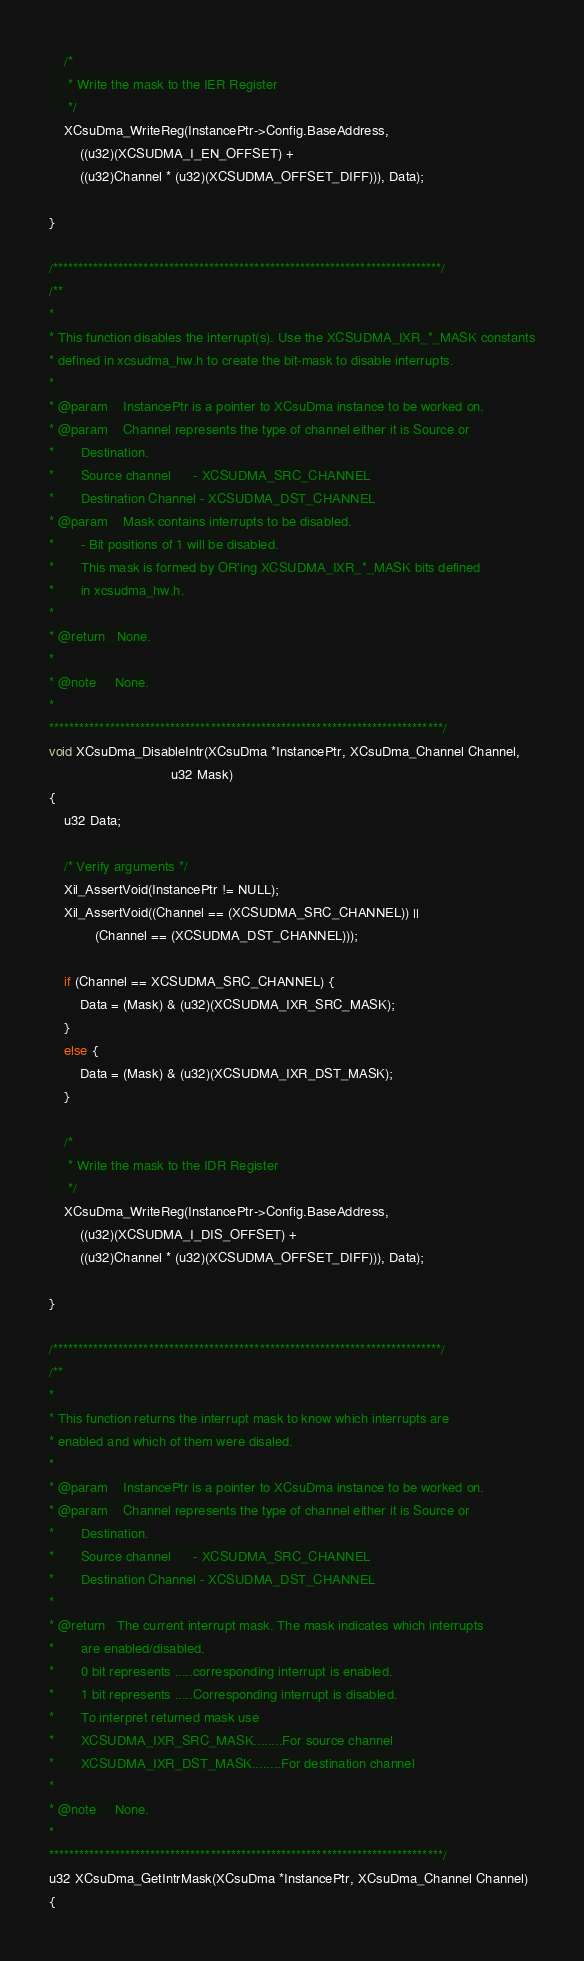<code> <loc_0><loc_0><loc_500><loc_500><_C_>	/*
	 * Write the mask to the IER Register
	 */
	XCsuDma_WriteReg(InstancePtr->Config.BaseAddress,
		((u32)(XCSUDMA_I_EN_OFFSET) +
		((u32)Channel * (u32)(XCSUDMA_OFFSET_DIFF))), Data);

}

/*****************************************************************************/
/**
*
* This function disables the interrupt(s). Use the XCSUDMA_IXR_*_MASK constants
* defined in xcsudma_hw.h to create the bit-mask to disable interrupts.
*
* @param	InstancePtr is a pointer to XCsuDma instance to be worked on.
* @param	Channel represents the type of channel either it is Source or
*		Destination.
*		Source channel      - XCSUDMA_SRC_CHANNEL
*		Destination Channel - XCSUDMA_DST_CHANNEL
* @param	Mask contains interrupts to be disabled.
*		- Bit positions of 1 will be disabled.
*		This mask is formed by OR'ing XCSUDMA_IXR_*_MASK bits defined
*		in xcsudma_hw.h.
*
* @return	None.
*
* @note		None.
*
******************************************************************************/
void XCsuDma_DisableIntr(XCsuDma *InstancePtr, XCsuDma_Channel Channel,
								u32 Mask)
{
	u32 Data;

	/* Verify arguments */
	Xil_AssertVoid(InstancePtr != NULL);
	Xil_AssertVoid((Channel == (XCSUDMA_SRC_CHANNEL)) ||
			(Channel == (XCSUDMA_DST_CHANNEL)));

	if (Channel == XCSUDMA_SRC_CHANNEL) {
		Data = (Mask) & (u32)(XCSUDMA_IXR_SRC_MASK);
	}
	else {
		Data = (Mask) & (u32)(XCSUDMA_IXR_DST_MASK);
	}

	/*
	 * Write the mask to the IDR Register
	 */
	XCsuDma_WriteReg(InstancePtr->Config.BaseAddress,
		((u32)(XCSUDMA_I_DIS_OFFSET) +
		((u32)Channel * (u32)(XCSUDMA_OFFSET_DIFF))), Data);

}

/*****************************************************************************/
/**
*
* This function returns the interrupt mask to know which interrupts are
* enabled and which of them were disaled.
*
* @param	InstancePtr is a pointer to XCsuDma instance to be worked on.
* @param	Channel represents the type of channel either it is Source or
*		Destination.
*		Source channel      - XCSUDMA_SRC_CHANNEL
*		Destination Channel - XCSUDMA_DST_CHANNEL
*
* @return	The current interrupt mask. The mask indicates which interrupts
*		are enabled/disabled.
*		0 bit represents .....corresponding interrupt is enabled.
*		1 bit represents .....Corresponding interrupt is disabled.
*		To interpret returned mask use
*		XCSUDMA_IXR_SRC_MASK........For source channel
*		XCSUDMA_IXR_DST_MASK........For destination channel
*
* @note		None.
*
******************************************************************************/
u32 XCsuDma_GetIntrMask(XCsuDma *InstancePtr, XCsuDma_Channel Channel)
{
</code> 